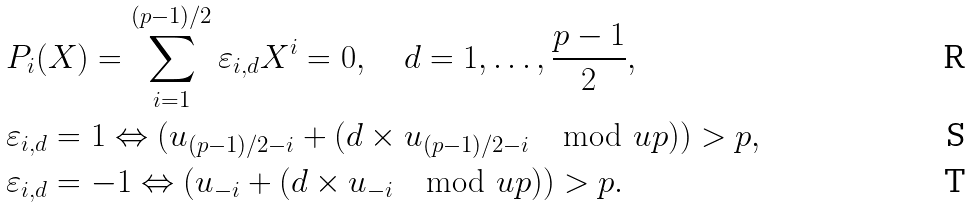Convert formula to latex. <formula><loc_0><loc_0><loc_500><loc_500>& P _ { i } ( X ) = \sum _ { i = 1 } ^ { ( p - 1 ) / 2 } \varepsilon _ { i , d } X ^ { i } = 0 , \quad d = 1 , \dots , \frac { p - 1 } { 2 } , \\ & \varepsilon _ { i , d } = 1 \Leftrightarrow ( u _ { ( p - 1 ) / 2 - i } + ( d \times u _ { ( p - 1 ) / 2 - i } \mod u p ) ) > p , \\ & \varepsilon _ { i , d } = - 1 \Leftrightarrow ( u _ { - i } + ( d \times u _ { - i } \mod u p ) ) > p .</formula> 